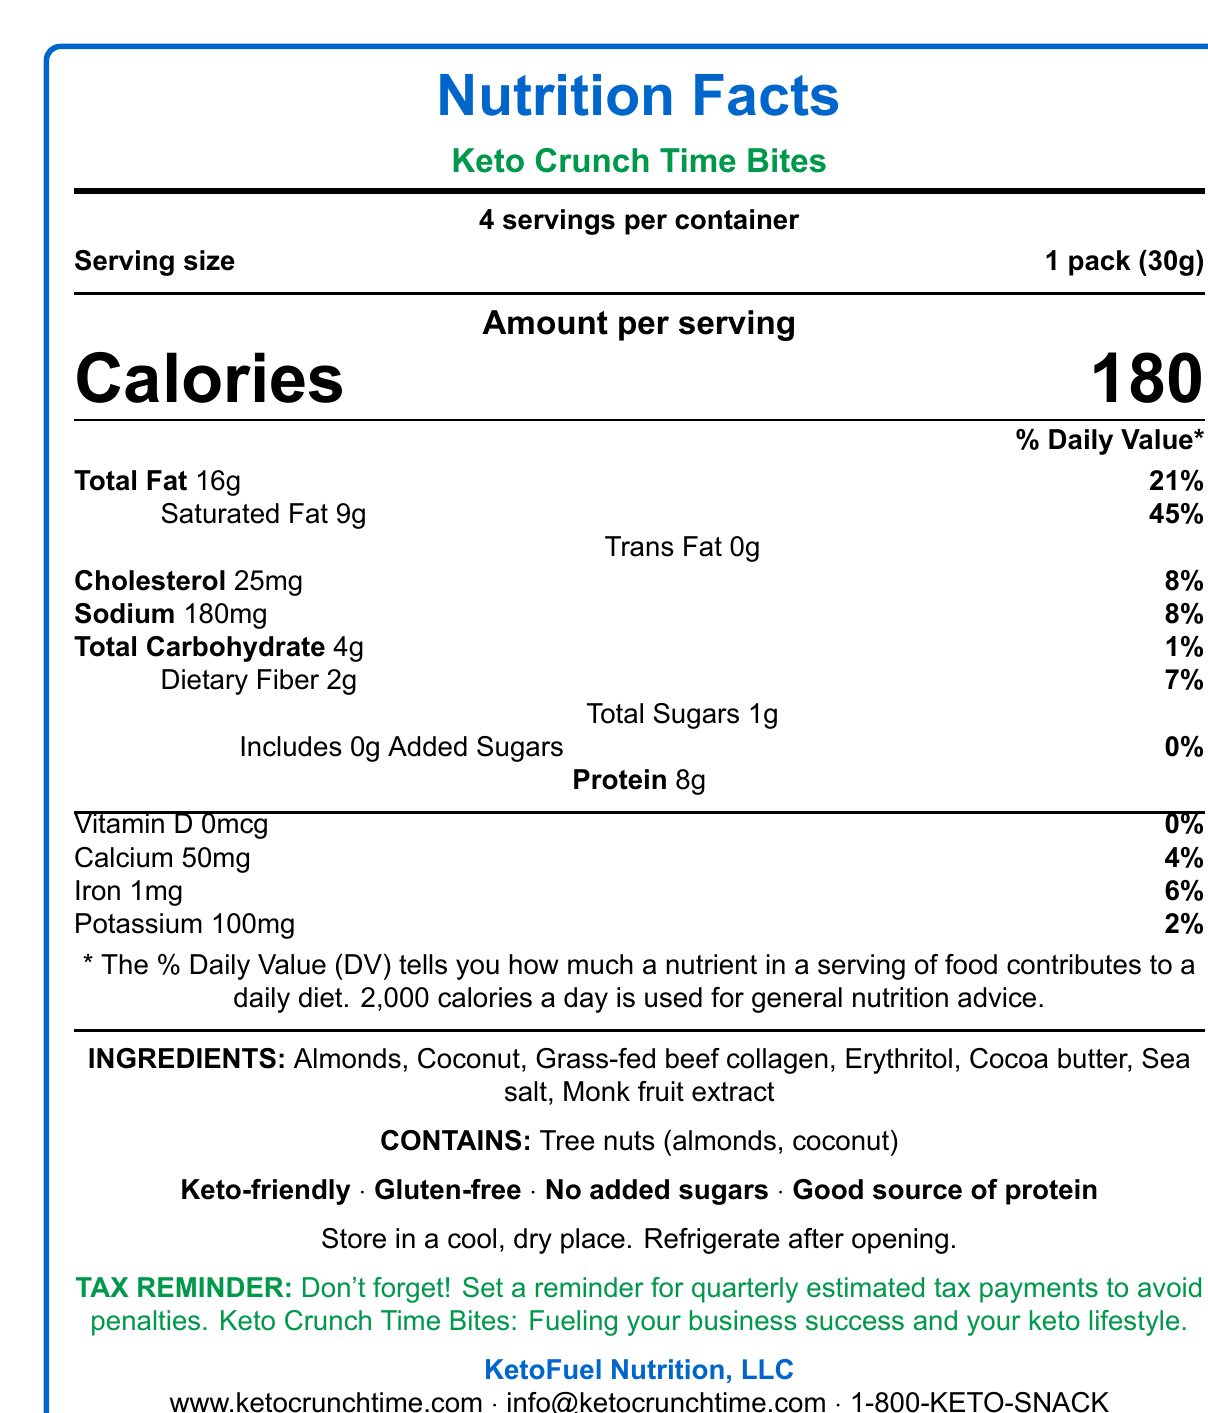what is the serving size of Keto Crunch Time Bites? The serving size is indicated in the nutritional information section as "1 pack (30g)."
Answer: 1 pack (30g) how many servings are there per container? The document specifies that there are 4 servings per container.
Answer: 4 how many calories are in one serving? The document lists the calorie content per serving as 180 calories.
Answer: 180 what is the total fat content per serving? The total fat content per serving is stated as 16 grams.
Answer: 16g how much protein does one serving contain? The document indicates that one serving contains 8 grams of protein.
Answer: 8g what allergens are contained in Keto Crunch Time Bites? The allergens listed are tree nuts, specifically almonds and coconut.
Answer: Tree nuts (almonds, coconut) what percentage of the Daily Value for saturated fat does one serving provide? The percentage of the Daily Value for saturated fat is listed as 45%.
Answer: 45% how much dietary fiber is in one serving? The dietary fiber content per serving is 2 grams.
Answer: 2g what is the sodium content per serving? The sodium content per serving is 180 milligrams.
Answer: 180mg what are the main ingredients in Keto Crunch Time Bites? The main ingredients are listed in the document.
Answer: Almonds, Coconut, Grass-fed beef collagen, Erythritol, Cocoa butter, Sea salt, Monk fruit extract are Keto Crunch Time Bites gluten-free? The document explicitly states that the product is gluten-free.
Answer: Yes what are some usage suggestions for Keto Crunch Time Bites? A. Quick snack between meetings B. Ideal for travel C. Pre-workout energy boost D. Pair with coffee for breakfast E. All of the above The usage suggestions listed include all of the above options.
Answer: E which company manufactures Keto Crunch Time Bites? A. KetoFuel Nutrition, LLC B. KetoLife Foods Inc. C. FitKeto Nutrition D. KetoSnack Co. The manufacturer is ketoFuel Nutrition, LLC.
Answer: A is the product keto-friendly? The document states that the product is keto-friendly.
Answer: Yes explain the main concept of the Keto Crunch Time Bites document. The main concept is to provide comprehensive nutritional and practical information about Keto Crunch Time Bites, a keto-friendly snack meant for busy professionals.
Answer: The document provides nutrition facts and additional product information about Keto Crunch Time Bites, a low-carb, high-fat snack designed for maintaining ketogenic diet adherence. It includes details on serving size, calorie count, fat, protein, and carbohydrate content, ingredients, allergens, health claims, storage instructions, the brand story, and usage suggestions. can the vitamin D content per serving be determined from the document? The vitamin D content per serving is listed as 0mcg, indicating no vitamin D is present. This metric would not reflect on determining its presence.
Answer: No 